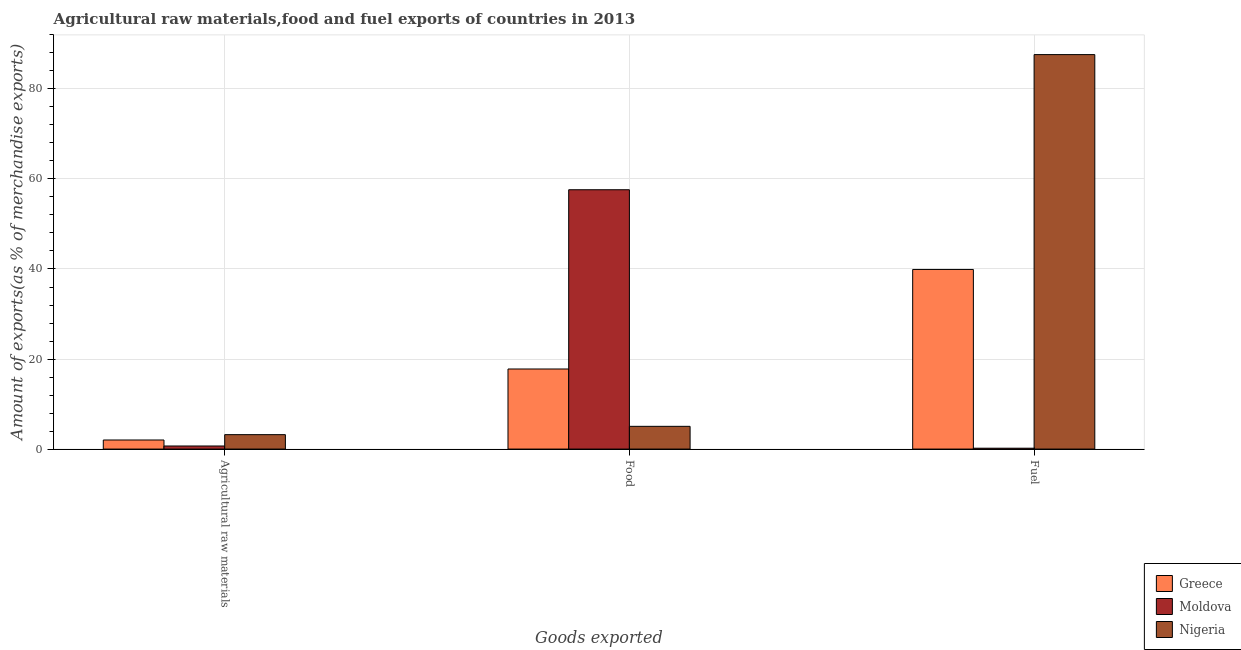How many different coloured bars are there?
Your answer should be very brief. 3. Are the number of bars on each tick of the X-axis equal?
Offer a very short reply. Yes. What is the label of the 2nd group of bars from the left?
Provide a succinct answer. Food. What is the percentage of food exports in Nigeria?
Keep it short and to the point. 5.05. Across all countries, what is the maximum percentage of food exports?
Provide a short and direct response. 57.6. Across all countries, what is the minimum percentage of food exports?
Provide a succinct answer. 5.05. In which country was the percentage of fuel exports maximum?
Provide a succinct answer. Nigeria. In which country was the percentage of fuel exports minimum?
Your answer should be very brief. Moldova. What is the total percentage of fuel exports in the graph?
Make the answer very short. 127.71. What is the difference between the percentage of food exports in Moldova and that in Nigeria?
Provide a succinct answer. 52.55. What is the difference between the percentage of fuel exports in Nigeria and the percentage of food exports in Moldova?
Your response must be concise. 30.02. What is the average percentage of raw materials exports per country?
Your answer should be compact. 1.97. What is the difference between the percentage of fuel exports and percentage of food exports in Nigeria?
Offer a terse response. 82.57. In how many countries, is the percentage of food exports greater than 52 %?
Keep it short and to the point. 1. What is the ratio of the percentage of raw materials exports in Nigeria to that in Greece?
Offer a terse response. 1.59. Is the difference between the percentage of raw materials exports in Moldova and Nigeria greater than the difference between the percentage of fuel exports in Moldova and Nigeria?
Offer a very short reply. Yes. What is the difference between the highest and the second highest percentage of raw materials exports?
Provide a short and direct response. 1.19. What is the difference between the highest and the lowest percentage of raw materials exports?
Provide a succinct answer. 2.52. Is the sum of the percentage of raw materials exports in Greece and Nigeria greater than the maximum percentage of food exports across all countries?
Your response must be concise. No. What does the 2nd bar from the left in Agricultural raw materials represents?
Offer a very short reply. Moldova. What does the 2nd bar from the right in Food represents?
Provide a succinct answer. Moldova. Is it the case that in every country, the sum of the percentage of raw materials exports and percentage of food exports is greater than the percentage of fuel exports?
Ensure brevity in your answer.  No. How many bars are there?
Give a very brief answer. 9. Are the values on the major ticks of Y-axis written in scientific E-notation?
Offer a very short reply. No. Does the graph contain any zero values?
Give a very brief answer. No. What is the title of the graph?
Keep it short and to the point. Agricultural raw materials,food and fuel exports of countries in 2013. Does "Saudi Arabia" appear as one of the legend labels in the graph?
Make the answer very short. No. What is the label or title of the X-axis?
Your answer should be very brief. Goods exported. What is the label or title of the Y-axis?
Your answer should be very brief. Amount of exports(as % of merchandise exports). What is the Amount of exports(as % of merchandise exports) of Greece in Agricultural raw materials?
Your response must be concise. 2.02. What is the Amount of exports(as % of merchandise exports) in Moldova in Agricultural raw materials?
Give a very brief answer. 0.68. What is the Amount of exports(as % of merchandise exports) of Nigeria in Agricultural raw materials?
Ensure brevity in your answer.  3.2. What is the Amount of exports(as % of merchandise exports) in Greece in Food?
Keep it short and to the point. 17.79. What is the Amount of exports(as % of merchandise exports) in Moldova in Food?
Provide a succinct answer. 57.6. What is the Amount of exports(as % of merchandise exports) in Nigeria in Food?
Your response must be concise. 5.05. What is the Amount of exports(as % of merchandise exports) in Greece in Fuel?
Offer a terse response. 39.9. What is the Amount of exports(as % of merchandise exports) in Moldova in Fuel?
Offer a very short reply. 0.19. What is the Amount of exports(as % of merchandise exports) of Nigeria in Fuel?
Ensure brevity in your answer.  87.62. Across all Goods exported, what is the maximum Amount of exports(as % of merchandise exports) in Greece?
Offer a terse response. 39.9. Across all Goods exported, what is the maximum Amount of exports(as % of merchandise exports) of Moldova?
Provide a succinct answer. 57.6. Across all Goods exported, what is the maximum Amount of exports(as % of merchandise exports) in Nigeria?
Give a very brief answer. 87.62. Across all Goods exported, what is the minimum Amount of exports(as % of merchandise exports) of Greece?
Offer a very short reply. 2.02. Across all Goods exported, what is the minimum Amount of exports(as % of merchandise exports) of Moldova?
Provide a short and direct response. 0.19. Across all Goods exported, what is the minimum Amount of exports(as % of merchandise exports) of Nigeria?
Provide a short and direct response. 3.2. What is the total Amount of exports(as % of merchandise exports) of Greece in the graph?
Offer a terse response. 59.7. What is the total Amount of exports(as % of merchandise exports) in Moldova in the graph?
Keep it short and to the point. 58.48. What is the total Amount of exports(as % of merchandise exports) of Nigeria in the graph?
Offer a terse response. 95.88. What is the difference between the Amount of exports(as % of merchandise exports) of Greece in Agricultural raw materials and that in Food?
Provide a succinct answer. -15.77. What is the difference between the Amount of exports(as % of merchandise exports) of Moldova in Agricultural raw materials and that in Food?
Offer a terse response. -56.92. What is the difference between the Amount of exports(as % of merchandise exports) in Nigeria in Agricultural raw materials and that in Food?
Give a very brief answer. -1.85. What is the difference between the Amount of exports(as % of merchandise exports) of Greece in Agricultural raw materials and that in Fuel?
Your response must be concise. -37.88. What is the difference between the Amount of exports(as % of merchandise exports) in Moldova in Agricultural raw materials and that in Fuel?
Give a very brief answer. 0.49. What is the difference between the Amount of exports(as % of merchandise exports) in Nigeria in Agricultural raw materials and that in Fuel?
Provide a succinct answer. -84.42. What is the difference between the Amount of exports(as % of merchandise exports) in Greece in Food and that in Fuel?
Make the answer very short. -22.11. What is the difference between the Amount of exports(as % of merchandise exports) in Moldova in Food and that in Fuel?
Your answer should be compact. 57.41. What is the difference between the Amount of exports(as % of merchandise exports) in Nigeria in Food and that in Fuel?
Your answer should be very brief. -82.57. What is the difference between the Amount of exports(as % of merchandise exports) of Greece in Agricultural raw materials and the Amount of exports(as % of merchandise exports) of Moldova in Food?
Keep it short and to the point. -55.59. What is the difference between the Amount of exports(as % of merchandise exports) in Greece in Agricultural raw materials and the Amount of exports(as % of merchandise exports) in Nigeria in Food?
Offer a terse response. -3.03. What is the difference between the Amount of exports(as % of merchandise exports) of Moldova in Agricultural raw materials and the Amount of exports(as % of merchandise exports) of Nigeria in Food?
Give a very brief answer. -4.37. What is the difference between the Amount of exports(as % of merchandise exports) in Greece in Agricultural raw materials and the Amount of exports(as % of merchandise exports) in Moldova in Fuel?
Keep it short and to the point. 1.82. What is the difference between the Amount of exports(as % of merchandise exports) in Greece in Agricultural raw materials and the Amount of exports(as % of merchandise exports) in Nigeria in Fuel?
Provide a succinct answer. -85.6. What is the difference between the Amount of exports(as % of merchandise exports) in Moldova in Agricultural raw materials and the Amount of exports(as % of merchandise exports) in Nigeria in Fuel?
Offer a very short reply. -86.94. What is the difference between the Amount of exports(as % of merchandise exports) of Greece in Food and the Amount of exports(as % of merchandise exports) of Moldova in Fuel?
Your answer should be compact. 17.6. What is the difference between the Amount of exports(as % of merchandise exports) in Greece in Food and the Amount of exports(as % of merchandise exports) in Nigeria in Fuel?
Give a very brief answer. -69.83. What is the difference between the Amount of exports(as % of merchandise exports) in Moldova in Food and the Amount of exports(as % of merchandise exports) in Nigeria in Fuel?
Provide a succinct answer. -30.02. What is the average Amount of exports(as % of merchandise exports) in Greece per Goods exported?
Give a very brief answer. 19.9. What is the average Amount of exports(as % of merchandise exports) of Moldova per Goods exported?
Offer a very short reply. 19.49. What is the average Amount of exports(as % of merchandise exports) of Nigeria per Goods exported?
Offer a terse response. 31.96. What is the difference between the Amount of exports(as % of merchandise exports) of Greece and Amount of exports(as % of merchandise exports) of Moldova in Agricultural raw materials?
Keep it short and to the point. 1.33. What is the difference between the Amount of exports(as % of merchandise exports) in Greece and Amount of exports(as % of merchandise exports) in Nigeria in Agricultural raw materials?
Your response must be concise. -1.19. What is the difference between the Amount of exports(as % of merchandise exports) of Moldova and Amount of exports(as % of merchandise exports) of Nigeria in Agricultural raw materials?
Your response must be concise. -2.52. What is the difference between the Amount of exports(as % of merchandise exports) of Greece and Amount of exports(as % of merchandise exports) of Moldova in Food?
Offer a very short reply. -39.82. What is the difference between the Amount of exports(as % of merchandise exports) in Greece and Amount of exports(as % of merchandise exports) in Nigeria in Food?
Give a very brief answer. 12.74. What is the difference between the Amount of exports(as % of merchandise exports) of Moldova and Amount of exports(as % of merchandise exports) of Nigeria in Food?
Offer a terse response. 52.55. What is the difference between the Amount of exports(as % of merchandise exports) of Greece and Amount of exports(as % of merchandise exports) of Moldova in Fuel?
Ensure brevity in your answer.  39.7. What is the difference between the Amount of exports(as % of merchandise exports) of Greece and Amount of exports(as % of merchandise exports) of Nigeria in Fuel?
Offer a very short reply. -47.73. What is the difference between the Amount of exports(as % of merchandise exports) of Moldova and Amount of exports(as % of merchandise exports) of Nigeria in Fuel?
Give a very brief answer. -87.43. What is the ratio of the Amount of exports(as % of merchandise exports) in Greece in Agricultural raw materials to that in Food?
Ensure brevity in your answer.  0.11. What is the ratio of the Amount of exports(as % of merchandise exports) of Moldova in Agricultural raw materials to that in Food?
Your answer should be very brief. 0.01. What is the ratio of the Amount of exports(as % of merchandise exports) in Nigeria in Agricultural raw materials to that in Food?
Your response must be concise. 0.63. What is the ratio of the Amount of exports(as % of merchandise exports) of Greece in Agricultural raw materials to that in Fuel?
Offer a very short reply. 0.05. What is the ratio of the Amount of exports(as % of merchandise exports) in Moldova in Agricultural raw materials to that in Fuel?
Provide a short and direct response. 3.54. What is the ratio of the Amount of exports(as % of merchandise exports) in Nigeria in Agricultural raw materials to that in Fuel?
Your answer should be compact. 0.04. What is the ratio of the Amount of exports(as % of merchandise exports) of Greece in Food to that in Fuel?
Provide a succinct answer. 0.45. What is the ratio of the Amount of exports(as % of merchandise exports) in Moldova in Food to that in Fuel?
Ensure brevity in your answer.  298.16. What is the ratio of the Amount of exports(as % of merchandise exports) of Nigeria in Food to that in Fuel?
Your answer should be compact. 0.06. What is the difference between the highest and the second highest Amount of exports(as % of merchandise exports) of Greece?
Ensure brevity in your answer.  22.11. What is the difference between the highest and the second highest Amount of exports(as % of merchandise exports) of Moldova?
Your response must be concise. 56.92. What is the difference between the highest and the second highest Amount of exports(as % of merchandise exports) of Nigeria?
Offer a terse response. 82.57. What is the difference between the highest and the lowest Amount of exports(as % of merchandise exports) in Greece?
Your answer should be compact. 37.88. What is the difference between the highest and the lowest Amount of exports(as % of merchandise exports) of Moldova?
Offer a terse response. 57.41. What is the difference between the highest and the lowest Amount of exports(as % of merchandise exports) in Nigeria?
Ensure brevity in your answer.  84.42. 